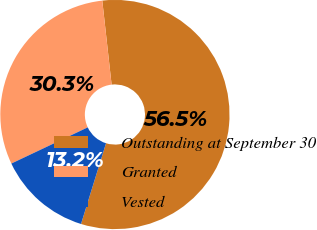Convert chart. <chart><loc_0><loc_0><loc_500><loc_500><pie_chart><fcel>Outstanding at September 30<fcel>Granted<fcel>Vested<nl><fcel>56.54%<fcel>30.28%<fcel>13.18%<nl></chart> 